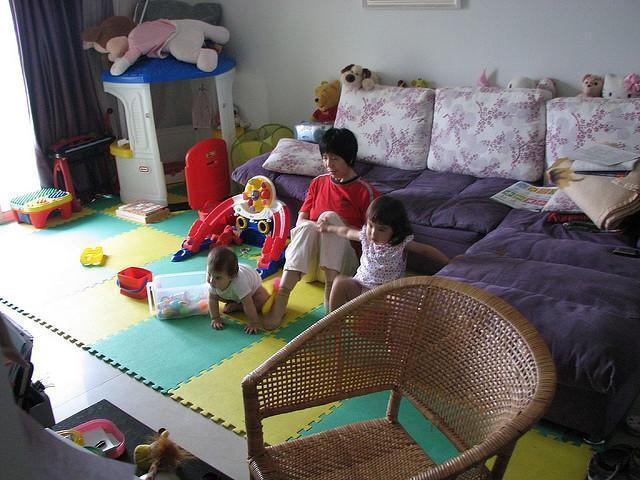How many pillows are on the couch?
Give a very brief answer. 4. How many humans are in the picture?
Give a very brief answer. 3. How many people are there?
Give a very brief answer. 3. How many people are riding the bike farthest to the left?
Give a very brief answer. 0. 